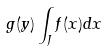<formula> <loc_0><loc_0><loc_500><loc_500>g ( y ) \int _ { J } f ( x ) d x</formula> 